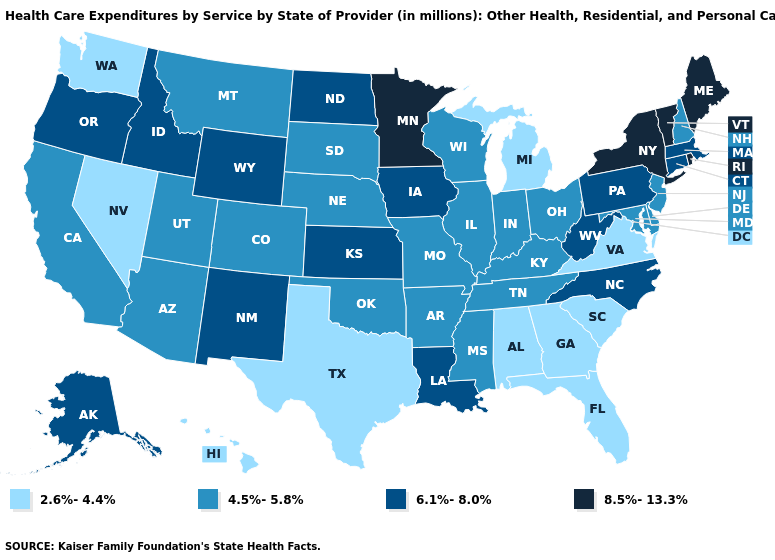Name the states that have a value in the range 4.5%-5.8%?
Quick response, please. Arizona, Arkansas, California, Colorado, Delaware, Illinois, Indiana, Kentucky, Maryland, Mississippi, Missouri, Montana, Nebraska, New Hampshire, New Jersey, Ohio, Oklahoma, South Dakota, Tennessee, Utah, Wisconsin. Which states have the lowest value in the MidWest?
Be succinct. Michigan. Does Iowa have a higher value than Colorado?
Concise answer only. Yes. Name the states that have a value in the range 6.1%-8.0%?
Write a very short answer. Alaska, Connecticut, Idaho, Iowa, Kansas, Louisiana, Massachusetts, New Mexico, North Carolina, North Dakota, Oregon, Pennsylvania, West Virginia, Wyoming. Name the states that have a value in the range 4.5%-5.8%?
Quick response, please. Arizona, Arkansas, California, Colorado, Delaware, Illinois, Indiana, Kentucky, Maryland, Mississippi, Missouri, Montana, Nebraska, New Hampshire, New Jersey, Ohio, Oklahoma, South Dakota, Tennessee, Utah, Wisconsin. Name the states that have a value in the range 4.5%-5.8%?
Answer briefly. Arizona, Arkansas, California, Colorado, Delaware, Illinois, Indiana, Kentucky, Maryland, Mississippi, Missouri, Montana, Nebraska, New Hampshire, New Jersey, Ohio, Oklahoma, South Dakota, Tennessee, Utah, Wisconsin. What is the lowest value in the West?
Write a very short answer. 2.6%-4.4%. Which states have the lowest value in the South?
Keep it brief. Alabama, Florida, Georgia, South Carolina, Texas, Virginia. What is the lowest value in states that border Arkansas?
Short answer required. 2.6%-4.4%. Name the states that have a value in the range 4.5%-5.8%?
Give a very brief answer. Arizona, Arkansas, California, Colorado, Delaware, Illinois, Indiana, Kentucky, Maryland, Mississippi, Missouri, Montana, Nebraska, New Hampshire, New Jersey, Ohio, Oklahoma, South Dakota, Tennessee, Utah, Wisconsin. Does New Jersey have a higher value than Florida?
Write a very short answer. Yes. Name the states that have a value in the range 2.6%-4.4%?
Answer briefly. Alabama, Florida, Georgia, Hawaii, Michigan, Nevada, South Carolina, Texas, Virginia, Washington. Which states have the lowest value in the USA?
Quick response, please. Alabama, Florida, Georgia, Hawaii, Michigan, Nevada, South Carolina, Texas, Virginia, Washington. Does the first symbol in the legend represent the smallest category?
Write a very short answer. Yes. Among the states that border Washington , which have the highest value?
Short answer required. Idaho, Oregon. 